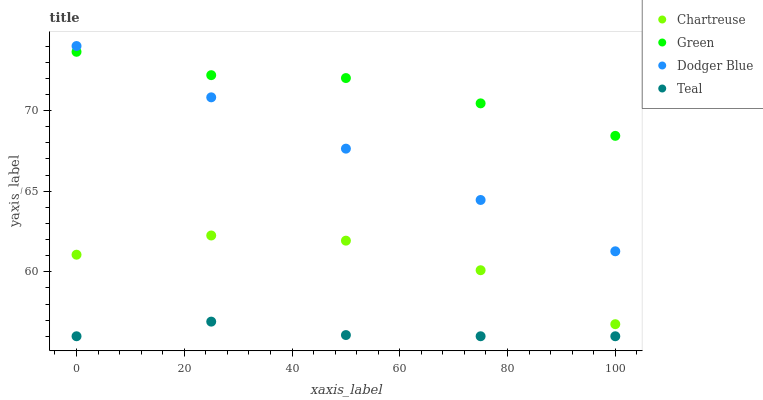Does Teal have the minimum area under the curve?
Answer yes or no. Yes. Does Green have the maximum area under the curve?
Answer yes or no. Yes. Does Chartreuse have the minimum area under the curve?
Answer yes or no. No. Does Chartreuse have the maximum area under the curve?
Answer yes or no. No. Is Dodger Blue the smoothest?
Answer yes or no. Yes. Is Chartreuse the roughest?
Answer yes or no. Yes. Is Green the smoothest?
Answer yes or no. No. Is Green the roughest?
Answer yes or no. No. Does Teal have the lowest value?
Answer yes or no. Yes. Does Chartreuse have the lowest value?
Answer yes or no. No. Does Dodger Blue have the highest value?
Answer yes or no. Yes. Does Chartreuse have the highest value?
Answer yes or no. No. Is Teal less than Dodger Blue?
Answer yes or no. Yes. Is Dodger Blue greater than Chartreuse?
Answer yes or no. Yes. Does Green intersect Dodger Blue?
Answer yes or no. Yes. Is Green less than Dodger Blue?
Answer yes or no. No. Is Green greater than Dodger Blue?
Answer yes or no. No. Does Teal intersect Dodger Blue?
Answer yes or no. No. 